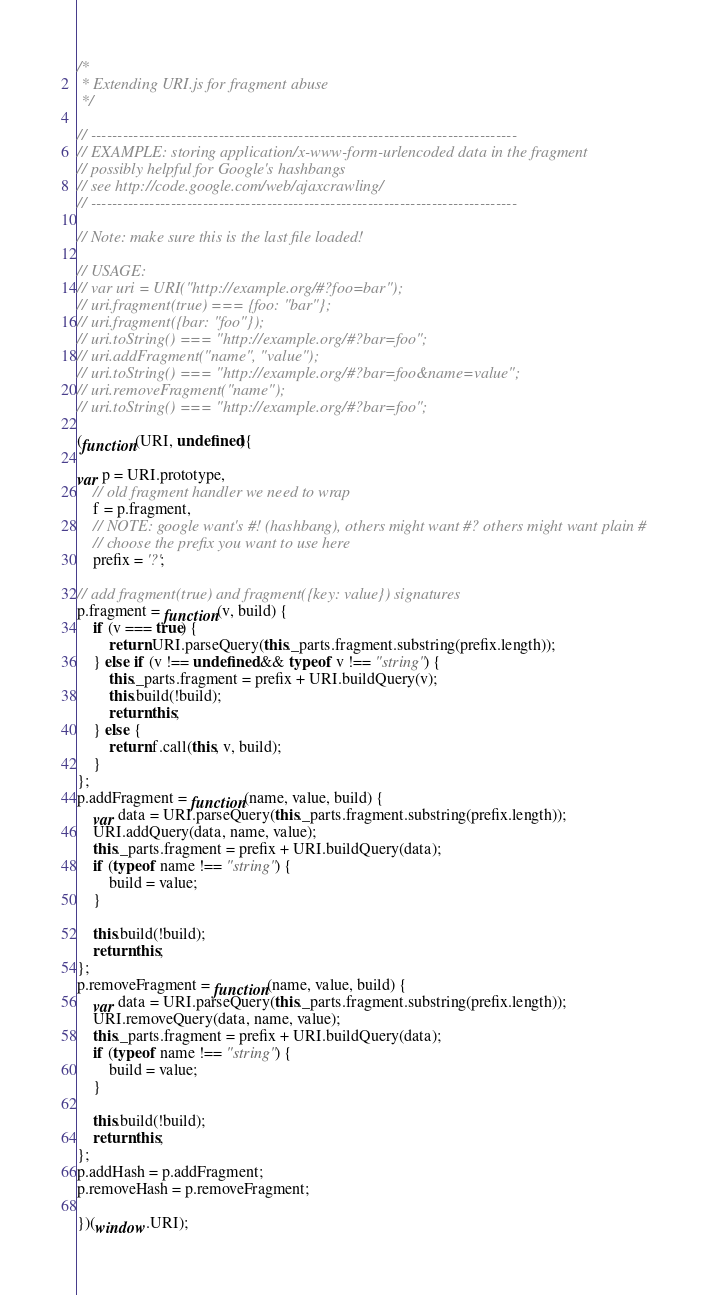Convert code to text. <code><loc_0><loc_0><loc_500><loc_500><_JavaScript_>/*
 * Extending URI.js for fragment abuse
 */

// --------------------------------------------------------------------------------
// EXAMPLE: storing application/x-www-form-urlencoded data in the fragment
// possibly helpful for Google's hashbangs
// see http://code.google.com/web/ajaxcrawling/
// --------------------------------------------------------------------------------

// Note: make sure this is the last file loaded!

// USAGE:
// var uri = URI("http://example.org/#?foo=bar");
// uri.fragment(true) === {foo: "bar"};
// uri.fragment({bar: "foo"});
// uri.toString() === "http://example.org/#?bar=foo";
// uri.addFragment("name", "value");
// uri.toString() === "http://example.org/#?bar=foo&name=value";
// uri.removeFragment("name");
// uri.toString() === "http://example.org/#?bar=foo";

(function(URI, undefined){

var p = URI.prototype,
    // old fragment handler we need to wrap
    f = p.fragment,
    // NOTE: google want's #! (hashbang), others might want #? others might want plain #
    // choose the prefix you want to use here
    prefix = '?';

// add fragment(true) and fragment({key: value}) signatures
p.fragment = function(v, build) {
    if (v === true) {
        return URI.parseQuery(this._parts.fragment.substring(prefix.length));
    } else if (v !== undefined && typeof v !== "string") {
        this._parts.fragment = prefix + URI.buildQuery(v);
        this.build(!build);
        return this;
    } else {
        return f.call(this, v, build);
    }
};
p.addFragment = function(name, value, build) {
    var data = URI.parseQuery(this._parts.fragment.substring(prefix.length));
    URI.addQuery(data, name, value);
    this._parts.fragment = prefix + URI.buildQuery(data);
    if (typeof name !== "string") {
        build = value;
    }

    this.build(!build);
    return this;
};
p.removeFragment = function(name, value, build) {
    var data = URI.parseQuery(this._parts.fragment.substring(prefix.length));
    URI.removeQuery(data, name, value);
    this._parts.fragment = prefix + URI.buildQuery(data);
    if (typeof name !== "string") {
        build = value;
    }

    this.build(!build);
    return this;
};
p.addHash = p.addFragment;
p.removeHash = p.removeFragment;

})(window.URI);
</code> 